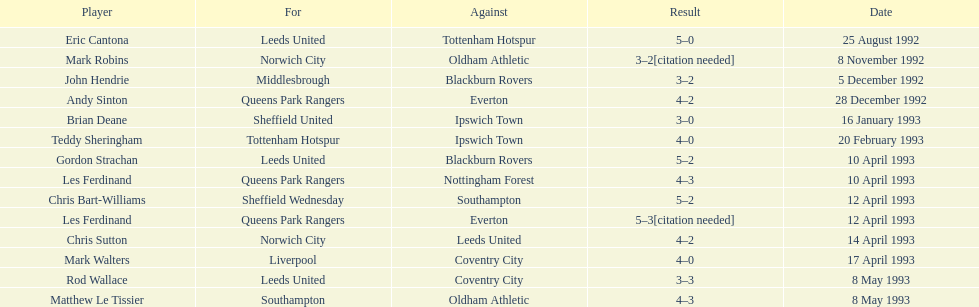What was the result of the match between queens park rangers and everton? 4-2. 